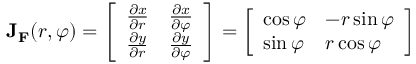<formula> <loc_0><loc_0><loc_500><loc_500>J _ { F } ( r , \varphi ) = { \left [ \begin{array} { l l } { { \frac { \partial x } { \partial r } } } & { { \frac { \partial x } { \partial \varphi } } } \\ { { \frac { \partial y } { \partial r } } } & { { \frac { \partial y } { \partial \varphi } } } \end{array} \right ] } = { \left [ \begin{array} { l l } { \cos \varphi } & { - r \sin \varphi } \\ { \sin \varphi } & { r \cos \varphi } \end{array} \right ] }</formula> 